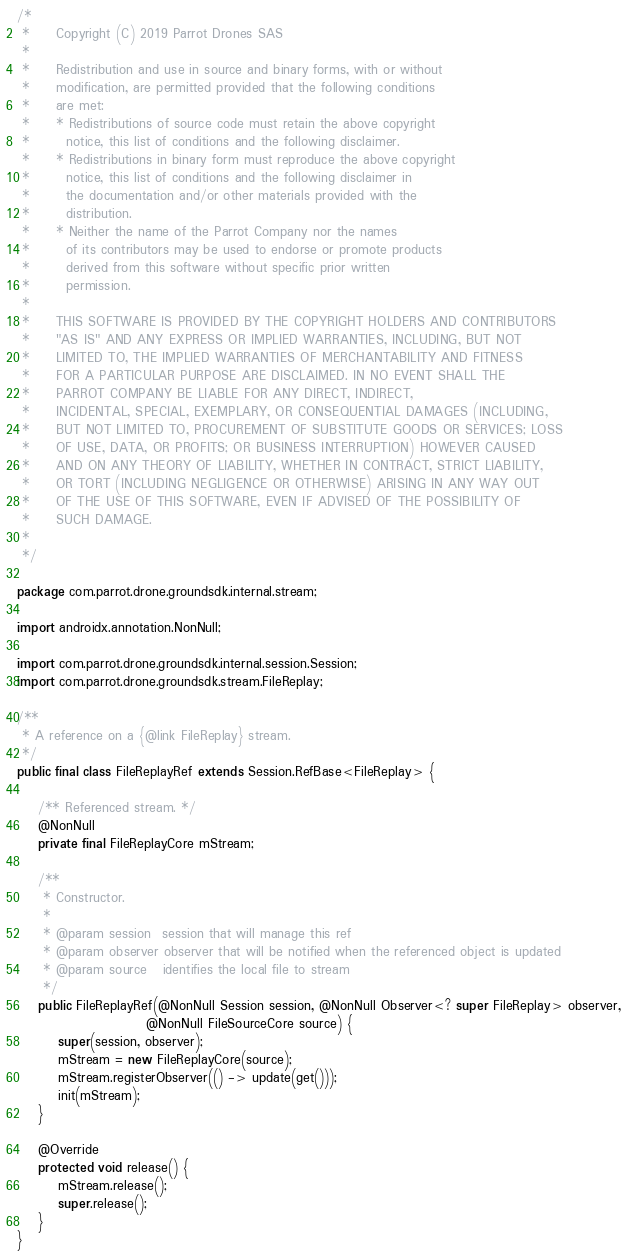<code> <loc_0><loc_0><loc_500><loc_500><_Java_>/*
 *     Copyright (C) 2019 Parrot Drones SAS
 *
 *     Redistribution and use in source and binary forms, with or without
 *     modification, are permitted provided that the following conditions
 *     are met:
 *     * Redistributions of source code must retain the above copyright
 *       notice, this list of conditions and the following disclaimer.
 *     * Redistributions in binary form must reproduce the above copyright
 *       notice, this list of conditions and the following disclaimer in
 *       the documentation and/or other materials provided with the
 *       distribution.
 *     * Neither the name of the Parrot Company nor the names
 *       of its contributors may be used to endorse or promote products
 *       derived from this software without specific prior written
 *       permission.
 *
 *     THIS SOFTWARE IS PROVIDED BY THE COPYRIGHT HOLDERS AND CONTRIBUTORS
 *     "AS IS" AND ANY EXPRESS OR IMPLIED WARRANTIES, INCLUDING, BUT NOT
 *     LIMITED TO, THE IMPLIED WARRANTIES OF MERCHANTABILITY AND FITNESS
 *     FOR A PARTICULAR PURPOSE ARE DISCLAIMED. IN NO EVENT SHALL THE
 *     PARROT COMPANY BE LIABLE FOR ANY DIRECT, INDIRECT,
 *     INCIDENTAL, SPECIAL, EXEMPLARY, OR CONSEQUENTIAL DAMAGES (INCLUDING,
 *     BUT NOT LIMITED TO, PROCUREMENT OF SUBSTITUTE GOODS OR SERVICES; LOSS
 *     OF USE, DATA, OR PROFITS; OR BUSINESS INTERRUPTION) HOWEVER CAUSED
 *     AND ON ANY THEORY OF LIABILITY, WHETHER IN CONTRACT, STRICT LIABILITY,
 *     OR TORT (INCLUDING NEGLIGENCE OR OTHERWISE) ARISING IN ANY WAY OUT
 *     OF THE USE OF THIS SOFTWARE, EVEN IF ADVISED OF THE POSSIBILITY OF
 *     SUCH DAMAGE.
 *
 */

package com.parrot.drone.groundsdk.internal.stream;

import androidx.annotation.NonNull;

import com.parrot.drone.groundsdk.internal.session.Session;
import com.parrot.drone.groundsdk.stream.FileReplay;

/**
 * A reference on a {@link FileReplay} stream.
 */
public final class FileReplayRef extends Session.RefBase<FileReplay> {

    /** Referenced stream. */
    @NonNull
    private final FileReplayCore mStream;

    /**
     * Constructor.
     *
     * @param session  session that will manage this ref
     * @param observer observer that will be notified when the referenced object is updated
     * @param source   identifies the local file to stream
     */
    public FileReplayRef(@NonNull Session session, @NonNull Observer<? super FileReplay> observer,
                         @NonNull FileSourceCore source) {
        super(session, observer);
        mStream = new FileReplayCore(source);
        mStream.registerObserver(() -> update(get()));
        init(mStream);
    }

    @Override
    protected void release() {
        mStream.release();
        super.release();
    }
}
</code> 